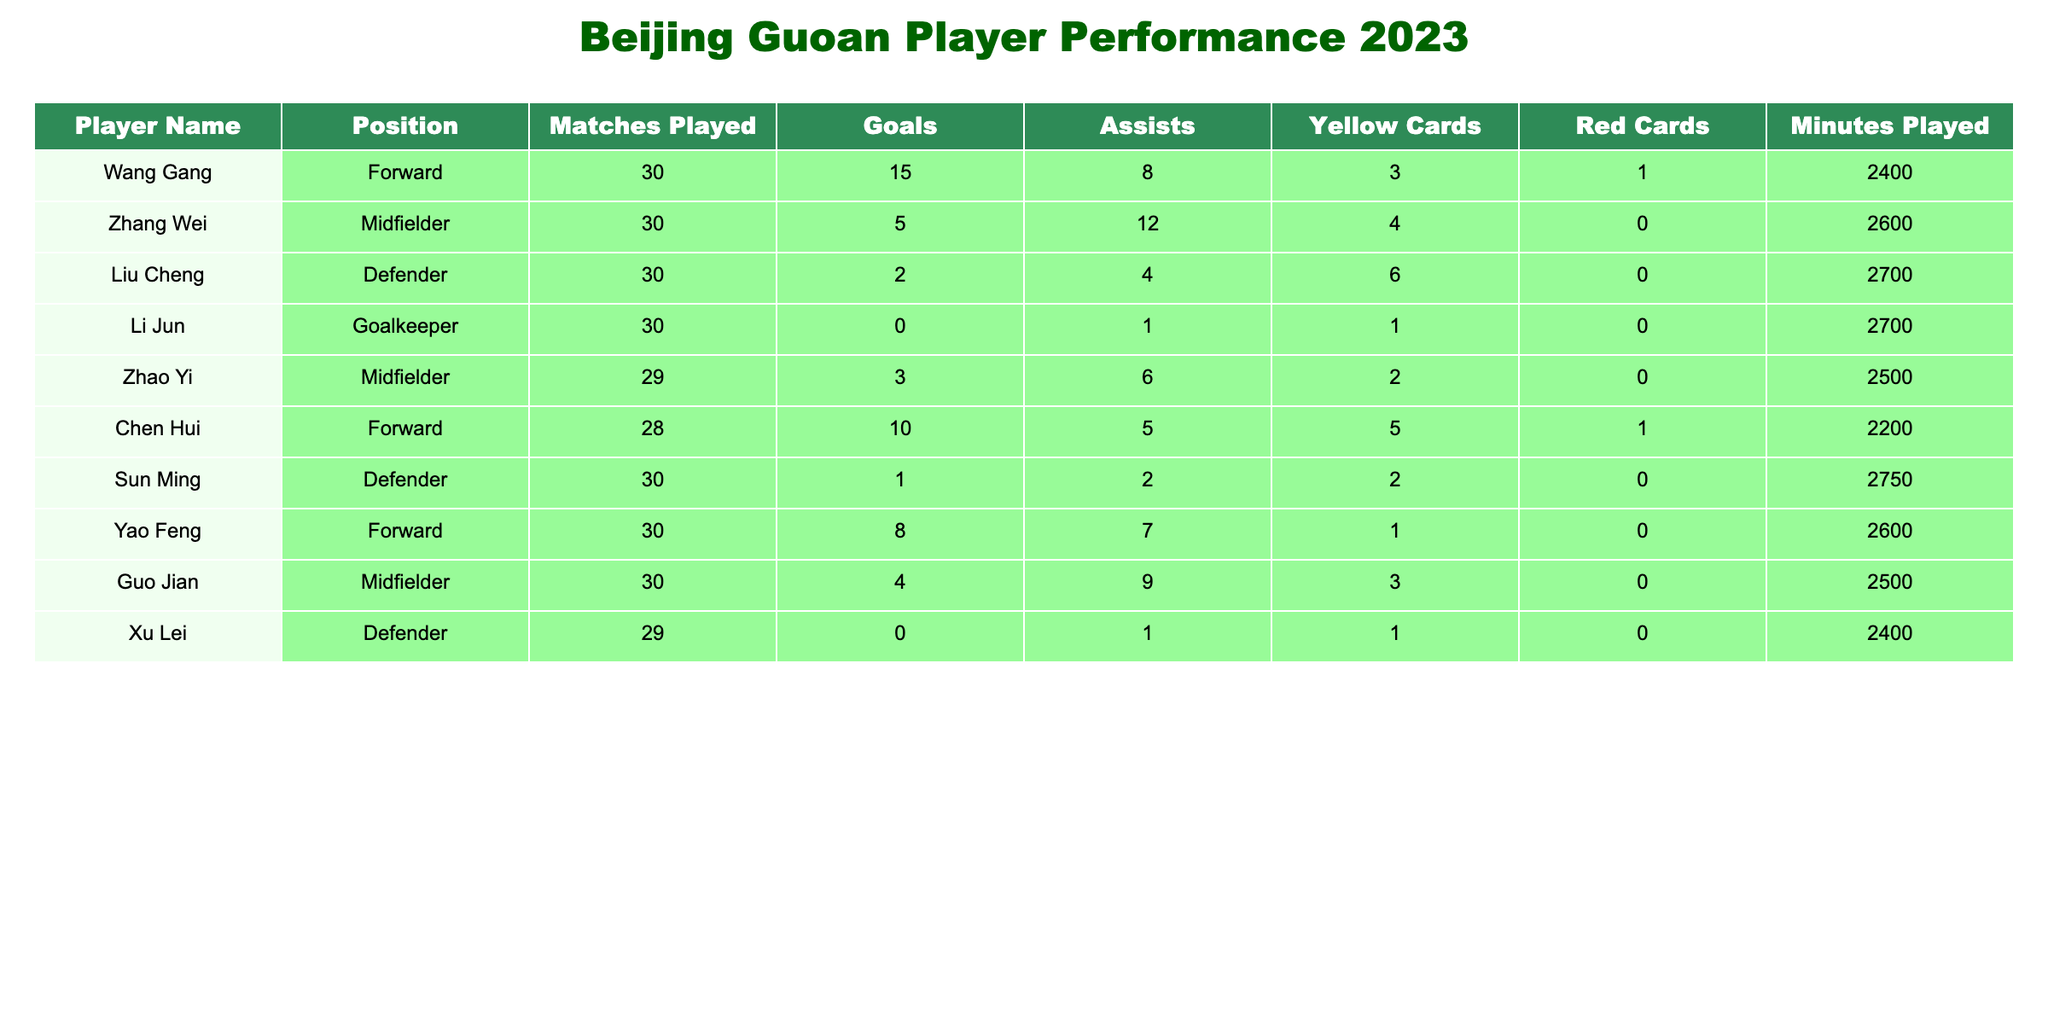What is the total number of goals scored by the forwards? The forwards listed are Wang Gang (15 goals), Chen Hui (10 goals), and Yao Feng (8 goals). Adding these together gives 15 + 10 + 8 = 33 goals.
Answer: 33 Who has the most assists in the season? Looking at the assists column, Zhang Wei has the highest with 12 assists.
Answer: Zhang Wei How many yellow cards did the defenders receive in total? The defenders are Liu Cheng (6 yellow cards), Sun Ming (2 yellow cards), and Xu Lei (1 yellow card). Summing these gives 6 + 2 + 1 = 9 yellow cards in total.
Answer: 9 Did any player receive more than 5 yellow cards? Liu Cheng received 6 yellow cards, which is greater than 5. Therefore, the statement is true.
Answer: Yes What is the average number of goals scored by the midfielders? The midfielders are Zhang Wei (5 goals), Zhao Yi (3 goals), and Guo Jian (4 goals). Adding these goals gives 5 + 3 + 4 = 12. The average is 12 goals divided by 3 players, which is 12 / 3 = 4.
Answer: 4 Which player played the most minutes and what is that number? Sun Ming played the most minutes with a total of 2750 minutes. Checking the minutes column, no other player exceeds this value.
Answer: 2750 How many total matches were played by players who scored at least 10 goals? Only Wang Gang (30 matches) and Chen Hui (28 matches) scored at least 10 goals. Adding their matches gives 30 + 28 = 58 matches played.
Answer: 58 Was there any player who played less than 2400 minutes? Xu Lei played 2400 minutes, while all other players played 2400 minutes or more. Therefore, no player played less than 2400 minutes.
Answer: No What is the difference in goals scored between the highest and the lowest goal-scorer? The highest goal-scorer is Wang Gang with 15 goals, and the lowest is Li Jun with 0 goals. The difference is 15 - 0 = 15 goals.
Answer: 15 